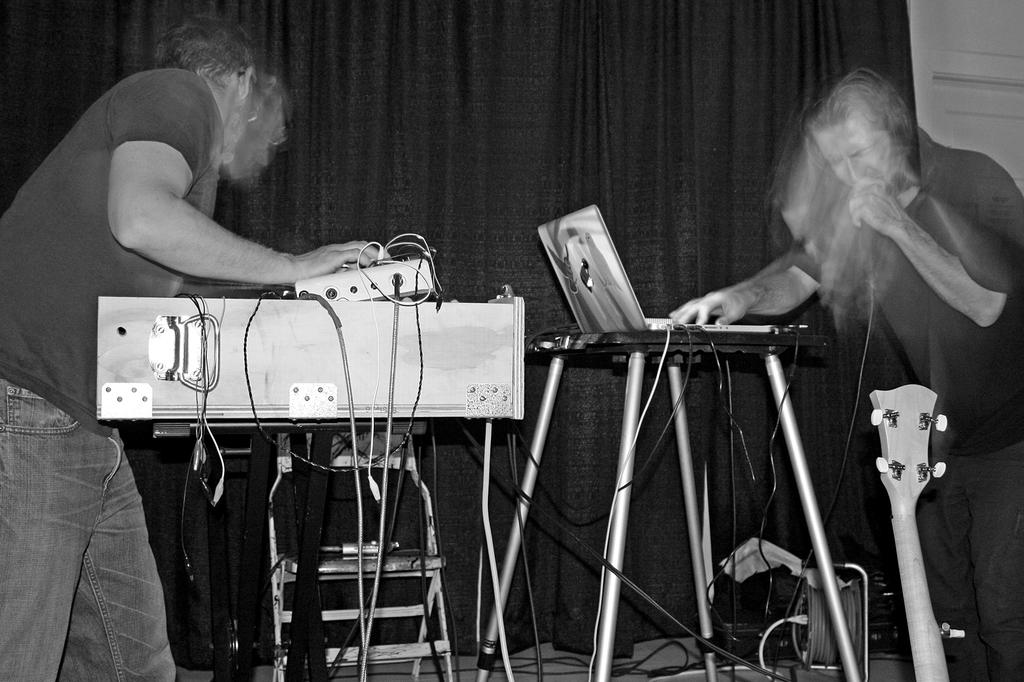What is present in the image that can be used for covering or separating spaces? There is a curtain in the image. How many people are visible in the image? There are two people standing in the image. What is the person on the right side holding? The person on the right side is holding a laptop. What musical instrument can be seen in the front of the image? There is a guitar in the front of the image. How many bikes are being used by the people in the image? There are no bikes present in the image. What list can be seen in the hands of the person on the right side? There is no list present in the image; the person on the right side is holding a laptop. 